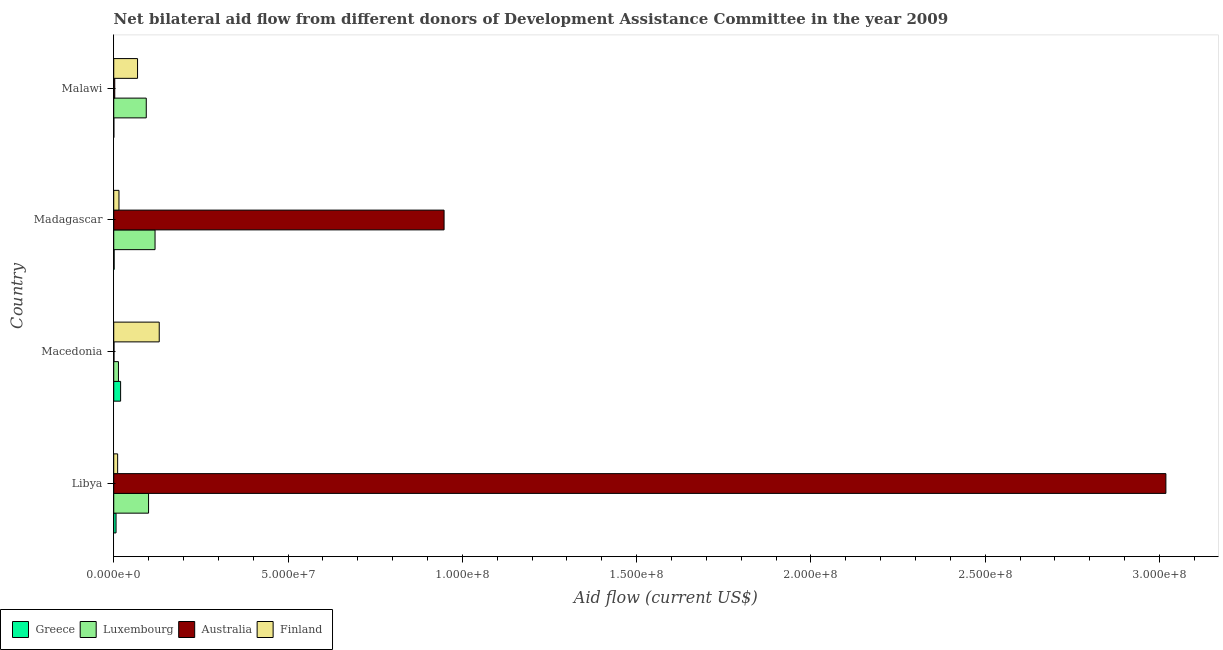How many groups of bars are there?
Make the answer very short. 4. Are the number of bars on each tick of the Y-axis equal?
Provide a succinct answer. Yes. How many bars are there on the 3rd tick from the top?
Make the answer very short. 4. How many bars are there on the 4th tick from the bottom?
Ensure brevity in your answer.  4. What is the label of the 4th group of bars from the top?
Offer a terse response. Libya. What is the amount of aid given by greece in Madagascar?
Provide a succinct answer. 1.10e+05. Across all countries, what is the maximum amount of aid given by australia?
Provide a short and direct response. 3.02e+08. Across all countries, what is the minimum amount of aid given by luxembourg?
Ensure brevity in your answer.  1.35e+06. In which country was the amount of aid given by luxembourg maximum?
Give a very brief answer. Madagascar. In which country was the amount of aid given by luxembourg minimum?
Offer a terse response. Macedonia. What is the total amount of aid given by greece in the graph?
Keep it short and to the point. 2.77e+06. What is the difference between the amount of aid given by australia in Macedonia and that in Madagascar?
Offer a very short reply. -9.47e+07. What is the difference between the amount of aid given by australia in Libya and the amount of aid given by luxembourg in Madagascar?
Provide a succinct answer. 2.90e+08. What is the average amount of aid given by australia per country?
Offer a very short reply. 9.92e+07. What is the difference between the amount of aid given by finland and amount of aid given by greece in Malawi?
Offer a very short reply. 6.80e+06. In how many countries, is the amount of aid given by greece greater than 200000000 US$?
Provide a succinct answer. 0. What is the ratio of the amount of aid given by greece in Macedonia to that in Madagascar?
Your answer should be very brief. 17.91. Is the amount of aid given by luxembourg in Macedonia less than that in Madagascar?
Your response must be concise. Yes. What is the difference between the highest and the second highest amount of aid given by australia?
Provide a short and direct response. 2.07e+08. What is the difference between the highest and the lowest amount of aid given by greece?
Provide a short and direct response. 1.94e+06. Is the sum of the amount of aid given by finland in Madagascar and Malawi greater than the maximum amount of aid given by greece across all countries?
Provide a short and direct response. Yes. What does the 1st bar from the bottom in Libya represents?
Ensure brevity in your answer.  Greece. Is it the case that in every country, the sum of the amount of aid given by greece and amount of aid given by luxembourg is greater than the amount of aid given by australia?
Keep it short and to the point. No. Are all the bars in the graph horizontal?
Provide a short and direct response. Yes. How many countries are there in the graph?
Provide a succinct answer. 4. Are the values on the major ticks of X-axis written in scientific E-notation?
Provide a succinct answer. Yes. Does the graph contain any zero values?
Offer a terse response. No. What is the title of the graph?
Offer a very short reply. Net bilateral aid flow from different donors of Development Assistance Committee in the year 2009. Does "Industry" appear as one of the legend labels in the graph?
Offer a terse response. No. What is the label or title of the Y-axis?
Give a very brief answer. Country. What is the Aid flow (current US$) of Greece in Libya?
Provide a short and direct response. 6.60e+05. What is the Aid flow (current US$) in Luxembourg in Libya?
Offer a terse response. 9.99e+06. What is the Aid flow (current US$) of Australia in Libya?
Offer a terse response. 3.02e+08. What is the Aid flow (current US$) of Finland in Libya?
Keep it short and to the point. 1.12e+06. What is the Aid flow (current US$) in Greece in Macedonia?
Your response must be concise. 1.97e+06. What is the Aid flow (current US$) in Luxembourg in Macedonia?
Make the answer very short. 1.35e+06. What is the Aid flow (current US$) of Australia in Macedonia?
Make the answer very short. 7.00e+04. What is the Aid flow (current US$) in Finland in Macedonia?
Provide a succinct answer. 1.30e+07. What is the Aid flow (current US$) in Greece in Madagascar?
Provide a succinct answer. 1.10e+05. What is the Aid flow (current US$) in Luxembourg in Madagascar?
Offer a very short reply. 1.18e+07. What is the Aid flow (current US$) in Australia in Madagascar?
Give a very brief answer. 9.48e+07. What is the Aid flow (current US$) in Finland in Madagascar?
Give a very brief answer. 1.50e+06. What is the Aid flow (current US$) of Greece in Malawi?
Keep it short and to the point. 3.00e+04. What is the Aid flow (current US$) in Luxembourg in Malawi?
Provide a short and direct response. 9.33e+06. What is the Aid flow (current US$) in Australia in Malawi?
Provide a short and direct response. 2.90e+05. What is the Aid flow (current US$) in Finland in Malawi?
Provide a short and direct response. 6.83e+06. Across all countries, what is the maximum Aid flow (current US$) in Greece?
Provide a short and direct response. 1.97e+06. Across all countries, what is the maximum Aid flow (current US$) of Luxembourg?
Your answer should be very brief. 1.18e+07. Across all countries, what is the maximum Aid flow (current US$) in Australia?
Keep it short and to the point. 3.02e+08. Across all countries, what is the maximum Aid flow (current US$) in Finland?
Your answer should be compact. 1.30e+07. Across all countries, what is the minimum Aid flow (current US$) of Greece?
Offer a very short reply. 3.00e+04. Across all countries, what is the minimum Aid flow (current US$) of Luxembourg?
Your answer should be compact. 1.35e+06. Across all countries, what is the minimum Aid flow (current US$) in Finland?
Offer a very short reply. 1.12e+06. What is the total Aid flow (current US$) of Greece in the graph?
Your answer should be very brief. 2.77e+06. What is the total Aid flow (current US$) in Luxembourg in the graph?
Make the answer very short. 3.25e+07. What is the total Aid flow (current US$) in Australia in the graph?
Keep it short and to the point. 3.97e+08. What is the total Aid flow (current US$) of Finland in the graph?
Offer a very short reply. 2.25e+07. What is the difference between the Aid flow (current US$) in Greece in Libya and that in Macedonia?
Ensure brevity in your answer.  -1.31e+06. What is the difference between the Aid flow (current US$) in Luxembourg in Libya and that in Macedonia?
Your response must be concise. 8.64e+06. What is the difference between the Aid flow (current US$) of Australia in Libya and that in Macedonia?
Make the answer very short. 3.02e+08. What is the difference between the Aid flow (current US$) in Finland in Libya and that in Macedonia?
Your answer should be very brief. -1.19e+07. What is the difference between the Aid flow (current US$) in Greece in Libya and that in Madagascar?
Your response must be concise. 5.50e+05. What is the difference between the Aid flow (current US$) in Luxembourg in Libya and that in Madagascar?
Provide a succinct answer. -1.86e+06. What is the difference between the Aid flow (current US$) of Australia in Libya and that in Madagascar?
Your answer should be compact. 2.07e+08. What is the difference between the Aid flow (current US$) in Finland in Libya and that in Madagascar?
Your response must be concise. -3.80e+05. What is the difference between the Aid flow (current US$) in Greece in Libya and that in Malawi?
Provide a short and direct response. 6.30e+05. What is the difference between the Aid flow (current US$) of Australia in Libya and that in Malawi?
Provide a short and direct response. 3.02e+08. What is the difference between the Aid flow (current US$) of Finland in Libya and that in Malawi?
Offer a very short reply. -5.71e+06. What is the difference between the Aid flow (current US$) in Greece in Macedonia and that in Madagascar?
Make the answer very short. 1.86e+06. What is the difference between the Aid flow (current US$) of Luxembourg in Macedonia and that in Madagascar?
Offer a terse response. -1.05e+07. What is the difference between the Aid flow (current US$) in Australia in Macedonia and that in Madagascar?
Your answer should be very brief. -9.47e+07. What is the difference between the Aid flow (current US$) in Finland in Macedonia and that in Madagascar?
Your answer should be compact. 1.16e+07. What is the difference between the Aid flow (current US$) of Greece in Macedonia and that in Malawi?
Your answer should be very brief. 1.94e+06. What is the difference between the Aid flow (current US$) in Luxembourg in Macedonia and that in Malawi?
Your answer should be very brief. -7.98e+06. What is the difference between the Aid flow (current US$) in Australia in Macedonia and that in Malawi?
Make the answer very short. -2.20e+05. What is the difference between the Aid flow (current US$) in Finland in Macedonia and that in Malawi?
Keep it short and to the point. 6.22e+06. What is the difference between the Aid flow (current US$) in Luxembourg in Madagascar and that in Malawi?
Your answer should be very brief. 2.52e+06. What is the difference between the Aid flow (current US$) in Australia in Madagascar and that in Malawi?
Your answer should be very brief. 9.45e+07. What is the difference between the Aid flow (current US$) in Finland in Madagascar and that in Malawi?
Offer a terse response. -5.33e+06. What is the difference between the Aid flow (current US$) of Greece in Libya and the Aid flow (current US$) of Luxembourg in Macedonia?
Your answer should be very brief. -6.90e+05. What is the difference between the Aid flow (current US$) of Greece in Libya and the Aid flow (current US$) of Australia in Macedonia?
Ensure brevity in your answer.  5.90e+05. What is the difference between the Aid flow (current US$) in Greece in Libya and the Aid flow (current US$) in Finland in Macedonia?
Provide a short and direct response. -1.24e+07. What is the difference between the Aid flow (current US$) in Luxembourg in Libya and the Aid flow (current US$) in Australia in Macedonia?
Provide a short and direct response. 9.92e+06. What is the difference between the Aid flow (current US$) in Luxembourg in Libya and the Aid flow (current US$) in Finland in Macedonia?
Your answer should be compact. -3.06e+06. What is the difference between the Aid flow (current US$) of Australia in Libya and the Aid flow (current US$) of Finland in Macedonia?
Offer a very short reply. 2.89e+08. What is the difference between the Aid flow (current US$) in Greece in Libya and the Aid flow (current US$) in Luxembourg in Madagascar?
Make the answer very short. -1.12e+07. What is the difference between the Aid flow (current US$) of Greece in Libya and the Aid flow (current US$) of Australia in Madagascar?
Your answer should be compact. -9.41e+07. What is the difference between the Aid flow (current US$) in Greece in Libya and the Aid flow (current US$) in Finland in Madagascar?
Give a very brief answer. -8.40e+05. What is the difference between the Aid flow (current US$) in Luxembourg in Libya and the Aid flow (current US$) in Australia in Madagascar?
Your answer should be compact. -8.48e+07. What is the difference between the Aid flow (current US$) in Luxembourg in Libya and the Aid flow (current US$) in Finland in Madagascar?
Offer a very short reply. 8.49e+06. What is the difference between the Aid flow (current US$) of Australia in Libya and the Aid flow (current US$) of Finland in Madagascar?
Provide a succinct answer. 3.00e+08. What is the difference between the Aid flow (current US$) of Greece in Libya and the Aid flow (current US$) of Luxembourg in Malawi?
Your answer should be compact. -8.67e+06. What is the difference between the Aid flow (current US$) in Greece in Libya and the Aid flow (current US$) in Australia in Malawi?
Your response must be concise. 3.70e+05. What is the difference between the Aid flow (current US$) in Greece in Libya and the Aid flow (current US$) in Finland in Malawi?
Provide a short and direct response. -6.17e+06. What is the difference between the Aid flow (current US$) of Luxembourg in Libya and the Aid flow (current US$) of Australia in Malawi?
Ensure brevity in your answer.  9.70e+06. What is the difference between the Aid flow (current US$) of Luxembourg in Libya and the Aid flow (current US$) of Finland in Malawi?
Give a very brief answer. 3.16e+06. What is the difference between the Aid flow (current US$) in Australia in Libya and the Aid flow (current US$) in Finland in Malawi?
Your response must be concise. 2.95e+08. What is the difference between the Aid flow (current US$) of Greece in Macedonia and the Aid flow (current US$) of Luxembourg in Madagascar?
Give a very brief answer. -9.88e+06. What is the difference between the Aid flow (current US$) of Greece in Macedonia and the Aid flow (current US$) of Australia in Madagascar?
Make the answer very short. -9.28e+07. What is the difference between the Aid flow (current US$) of Luxembourg in Macedonia and the Aid flow (current US$) of Australia in Madagascar?
Make the answer very short. -9.34e+07. What is the difference between the Aid flow (current US$) of Australia in Macedonia and the Aid flow (current US$) of Finland in Madagascar?
Offer a terse response. -1.43e+06. What is the difference between the Aid flow (current US$) of Greece in Macedonia and the Aid flow (current US$) of Luxembourg in Malawi?
Your response must be concise. -7.36e+06. What is the difference between the Aid flow (current US$) of Greece in Macedonia and the Aid flow (current US$) of Australia in Malawi?
Give a very brief answer. 1.68e+06. What is the difference between the Aid flow (current US$) in Greece in Macedonia and the Aid flow (current US$) in Finland in Malawi?
Give a very brief answer. -4.86e+06. What is the difference between the Aid flow (current US$) of Luxembourg in Macedonia and the Aid flow (current US$) of Australia in Malawi?
Ensure brevity in your answer.  1.06e+06. What is the difference between the Aid flow (current US$) of Luxembourg in Macedonia and the Aid flow (current US$) of Finland in Malawi?
Give a very brief answer. -5.48e+06. What is the difference between the Aid flow (current US$) in Australia in Macedonia and the Aid flow (current US$) in Finland in Malawi?
Keep it short and to the point. -6.76e+06. What is the difference between the Aid flow (current US$) of Greece in Madagascar and the Aid flow (current US$) of Luxembourg in Malawi?
Make the answer very short. -9.22e+06. What is the difference between the Aid flow (current US$) of Greece in Madagascar and the Aid flow (current US$) of Australia in Malawi?
Keep it short and to the point. -1.80e+05. What is the difference between the Aid flow (current US$) of Greece in Madagascar and the Aid flow (current US$) of Finland in Malawi?
Offer a very short reply. -6.72e+06. What is the difference between the Aid flow (current US$) of Luxembourg in Madagascar and the Aid flow (current US$) of Australia in Malawi?
Provide a short and direct response. 1.16e+07. What is the difference between the Aid flow (current US$) in Luxembourg in Madagascar and the Aid flow (current US$) in Finland in Malawi?
Make the answer very short. 5.02e+06. What is the difference between the Aid flow (current US$) of Australia in Madagascar and the Aid flow (current US$) of Finland in Malawi?
Make the answer very short. 8.79e+07. What is the average Aid flow (current US$) of Greece per country?
Make the answer very short. 6.92e+05. What is the average Aid flow (current US$) in Luxembourg per country?
Your answer should be compact. 8.13e+06. What is the average Aid flow (current US$) of Australia per country?
Ensure brevity in your answer.  9.92e+07. What is the average Aid flow (current US$) of Finland per country?
Give a very brief answer. 5.62e+06. What is the difference between the Aid flow (current US$) in Greece and Aid flow (current US$) in Luxembourg in Libya?
Ensure brevity in your answer.  -9.33e+06. What is the difference between the Aid flow (current US$) of Greece and Aid flow (current US$) of Australia in Libya?
Keep it short and to the point. -3.01e+08. What is the difference between the Aid flow (current US$) of Greece and Aid flow (current US$) of Finland in Libya?
Keep it short and to the point. -4.60e+05. What is the difference between the Aid flow (current US$) of Luxembourg and Aid flow (current US$) of Australia in Libya?
Your response must be concise. -2.92e+08. What is the difference between the Aid flow (current US$) of Luxembourg and Aid flow (current US$) of Finland in Libya?
Give a very brief answer. 8.87e+06. What is the difference between the Aid flow (current US$) of Australia and Aid flow (current US$) of Finland in Libya?
Keep it short and to the point. 3.01e+08. What is the difference between the Aid flow (current US$) of Greece and Aid flow (current US$) of Luxembourg in Macedonia?
Give a very brief answer. 6.20e+05. What is the difference between the Aid flow (current US$) in Greece and Aid flow (current US$) in Australia in Macedonia?
Offer a very short reply. 1.90e+06. What is the difference between the Aid flow (current US$) in Greece and Aid flow (current US$) in Finland in Macedonia?
Offer a terse response. -1.11e+07. What is the difference between the Aid flow (current US$) of Luxembourg and Aid flow (current US$) of Australia in Macedonia?
Provide a succinct answer. 1.28e+06. What is the difference between the Aid flow (current US$) of Luxembourg and Aid flow (current US$) of Finland in Macedonia?
Make the answer very short. -1.17e+07. What is the difference between the Aid flow (current US$) of Australia and Aid flow (current US$) of Finland in Macedonia?
Keep it short and to the point. -1.30e+07. What is the difference between the Aid flow (current US$) in Greece and Aid flow (current US$) in Luxembourg in Madagascar?
Keep it short and to the point. -1.17e+07. What is the difference between the Aid flow (current US$) in Greece and Aid flow (current US$) in Australia in Madagascar?
Ensure brevity in your answer.  -9.47e+07. What is the difference between the Aid flow (current US$) in Greece and Aid flow (current US$) in Finland in Madagascar?
Your answer should be very brief. -1.39e+06. What is the difference between the Aid flow (current US$) in Luxembourg and Aid flow (current US$) in Australia in Madagascar?
Give a very brief answer. -8.29e+07. What is the difference between the Aid flow (current US$) in Luxembourg and Aid flow (current US$) in Finland in Madagascar?
Offer a terse response. 1.04e+07. What is the difference between the Aid flow (current US$) of Australia and Aid flow (current US$) of Finland in Madagascar?
Provide a short and direct response. 9.33e+07. What is the difference between the Aid flow (current US$) in Greece and Aid flow (current US$) in Luxembourg in Malawi?
Keep it short and to the point. -9.30e+06. What is the difference between the Aid flow (current US$) of Greece and Aid flow (current US$) of Finland in Malawi?
Keep it short and to the point. -6.80e+06. What is the difference between the Aid flow (current US$) of Luxembourg and Aid flow (current US$) of Australia in Malawi?
Offer a terse response. 9.04e+06. What is the difference between the Aid flow (current US$) of Luxembourg and Aid flow (current US$) of Finland in Malawi?
Ensure brevity in your answer.  2.50e+06. What is the difference between the Aid flow (current US$) in Australia and Aid flow (current US$) in Finland in Malawi?
Your response must be concise. -6.54e+06. What is the ratio of the Aid flow (current US$) of Greece in Libya to that in Macedonia?
Give a very brief answer. 0.34. What is the ratio of the Aid flow (current US$) in Australia in Libya to that in Macedonia?
Ensure brevity in your answer.  4312.14. What is the ratio of the Aid flow (current US$) in Finland in Libya to that in Macedonia?
Your answer should be very brief. 0.09. What is the ratio of the Aid flow (current US$) in Luxembourg in Libya to that in Madagascar?
Ensure brevity in your answer.  0.84. What is the ratio of the Aid flow (current US$) of Australia in Libya to that in Madagascar?
Your answer should be very brief. 3.19. What is the ratio of the Aid flow (current US$) in Finland in Libya to that in Madagascar?
Provide a short and direct response. 0.75. What is the ratio of the Aid flow (current US$) of Greece in Libya to that in Malawi?
Offer a very short reply. 22. What is the ratio of the Aid flow (current US$) in Luxembourg in Libya to that in Malawi?
Ensure brevity in your answer.  1.07. What is the ratio of the Aid flow (current US$) of Australia in Libya to that in Malawi?
Offer a very short reply. 1040.86. What is the ratio of the Aid flow (current US$) in Finland in Libya to that in Malawi?
Ensure brevity in your answer.  0.16. What is the ratio of the Aid flow (current US$) of Greece in Macedonia to that in Madagascar?
Offer a terse response. 17.91. What is the ratio of the Aid flow (current US$) in Luxembourg in Macedonia to that in Madagascar?
Your answer should be compact. 0.11. What is the ratio of the Aid flow (current US$) of Australia in Macedonia to that in Madagascar?
Your answer should be compact. 0. What is the ratio of the Aid flow (current US$) in Finland in Macedonia to that in Madagascar?
Ensure brevity in your answer.  8.7. What is the ratio of the Aid flow (current US$) in Greece in Macedonia to that in Malawi?
Keep it short and to the point. 65.67. What is the ratio of the Aid flow (current US$) in Luxembourg in Macedonia to that in Malawi?
Offer a terse response. 0.14. What is the ratio of the Aid flow (current US$) in Australia in Macedonia to that in Malawi?
Your answer should be compact. 0.24. What is the ratio of the Aid flow (current US$) of Finland in Macedonia to that in Malawi?
Your answer should be compact. 1.91. What is the ratio of the Aid flow (current US$) of Greece in Madagascar to that in Malawi?
Make the answer very short. 3.67. What is the ratio of the Aid flow (current US$) in Luxembourg in Madagascar to that in Malawi?
Provide a short and direct response. 1.27. What is the ratio of the Aid flow (current US$) in Australia in Madagascar to that in Malawi?
Give a very brief answer. 326.79. What is the ratio of the Aid flow (current US$) in Finland in Madagascar to that in Malawi?
Give a very brief answer. 0.22. What is the difference between the highest and the second highest Aid flow (current US$) of Greece?
Offer a very short reply. 1.31e+06. What is the difference between the highest and the second highest Aid flow (current US$) of Luxembourg?
Give a very brief answer. 1.86e+06. What is the difference between the highest and the second highest Aid flow (current US$) in Australia?
Your response must be concise. 2.07e+08. What is the difference between the highest and the second highest Aid flow (current US$) of Finland?
Provide a short and direct response. 6.22e+06. What is the difference between the highest and the lowest Aid flow (current US$) of Greece?
Give a very brief answer. 1.94e+06. What is the difference between the highest and the lowest Aid flow (current US$) in Luxembourg?
Your response must be concise. 1.05e+07. What is the difference between the highest and the lowest Aid flow (current US$) of Australia?
Provide a succinct answer. 3.02e+08. What is the difference between the highest and the lowest Aid flow (current US$) of Finland?
Your answer should be very brief. 1.19e+07. 